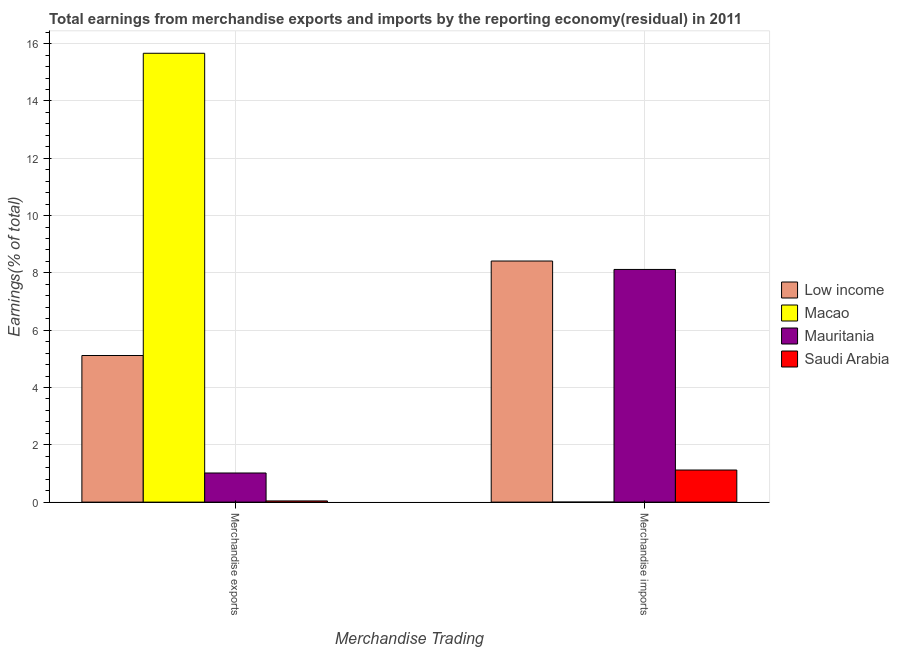Are the number of bars on each tick of the X-axis equal?
Your answer should be compact. No. How many bars are there on the 1st tick from the left?
Your answer should be very brief. 4. How many bars are there on the 1st tick from the right?
Your answer should be compact. 3. What is the earnings from merchandise exports in Macao?
Provide a succinct answer. 15.67. Across all countries, what is the maximum earnings from merchandise exports?
Your answer should be compact. 15.67. Across all countries, what is the minimum earnings from merchandise exports?
Give a very brief answer. 0.04. In which country was the earnings from merchandise exports maximum?
Your answer should be compact. Macao. What is the total earnings from merchandise imports in the graph?
Make the answer very short. 17.66. What is the difference between the earnings from merchandise exports in Low income and that in Macao?
Your response must be concise. -10.55. What is the difference between the earnings from merchandise exports in Mauritania and the earnings from merchandise imports in Low income?
Provide a succinct answer. -7.4. What is the average earnings from merchandise imports per country?
Provide a succinct answer. 4.41. What is the difference between the earnings from merchandise exports and earnings from merchandise imports in Mauritania?
Offer a terse response. -7.1. What is the ratio of the earnings from merchandise imports in Mauritania to that in Saudi Arabia?
Provide a succinct answer. 7.25. How many bars are there?
Offer a very short reply. 7. What is the difference between two consecutive major ticks on the Y-axis?
Give a very brief answer. 2. Does the graph contain any zero values?
Make the answer very short. Yes. Where does the legend appear in the graph?
Your answer should be compact. Center right. How are the legend labels stacked?
Your answer should be compact. Vertical. What is the title of the graph?
Provide a succinct answer. Total earnings from merchandise exports and imports by the reporting economy(residual) in 2011. What is the label or title of the X-axis?
Ensure brevity in your answer.  Merchandise Trading. What is the label or title of the Y-axis?
Keep it short and to the point. Earnings(% of total). What is the Earnings(% of total) in Low income in Merchandise exports?
Offer a very short reply. 5.12. What is the Earnings(% of total) of Macao in Merchandise exports?
Offer a terse response. 15.67. What is the Earnings(% of total) of Mauritania in Merchandise exports?
Keep it short and to the point. 1.02. What is the Earnings(% of total) in Saudi Arabia in Merchandise exports?
Your answer should be very brief. 0.04. What is the Earnings(% of total) of Low income in Merchandise imports?
Keep it short and to the point. 8.42. What is the Earnings(% of total) of Mauritania in Merchandise imports?
Make the answer very short. 8.12. What is the Earnings(% of total) of Saudi Arabia in Merchandise imports?
Offer a very short reply. 1.12. Across all Merchandise Trading, what is the maximum Earnings(% of total) of Low income?
Your answer should be compact. 8.42. Across all Merchandise Trading, what is the maximum Earnings(% of total) of Macao?
Make the answer very short. 15.67. Across all Merchandise Trading, what is the maximum Earnings(% of total) in Mauritania?
Your answer should be very brief. 8.12. Across all Merchandise Trading, what is the maximum Earnings(% of total) in Saudi Arabia?
Your response must be concise. 1.12. Across all Merchandise Trading, what is the minimum Earnings(% of total) of Low income?
Your answer should be very brief. 5.12. Across all Merchandise Trading, what is the minimum Earnings(% of total) in Mauritania?
Make the answer very short. 1.02. Across all Merchandise Trading, what is the minimum Earnings(% of total) in Saudi Arabia?
Offer a terse response. 0.04. What is the total Earnings(% of total) of Low income in the graph?
Your answer should be very brief. 13.53. What is the total Earnings(% of total) of Macao in the graph?
Your answer should be very brief. 15.67. What is the total Earnings(% of total) of Mauritania in the graph?
Give a very brief answer. 9.14. What is the total Earnings(% of total) in Saudi Arabia in the graph?
Your answer should be compact. 1.16. What is the difference between the Earnings(% of total) in Low income in Merchandise exports and that in Merchandise imports?
Give a very brief answer. -3.3. What is the difference between the Earnings(% of total) of Mauritania in Merchandise exports and that in Merchandise imports?
Make the answer very short. -7.1. What is the difference between the Earnings(% of total) of Saudi Arabia in Merchandise exports and that in Merchandise imports?
Your response must be concise. -1.08. What is the difference between the Earnings(% of total) of Low income in Merchandise exports and the Earnings(% of total) of Mauritania in Merchandise imports?
Offer a terse response. -3. What is the difference between the Earnings(% of total) of Low income in Merchandise exports and the Earnings(% of total) of Saudi Arabia in Merchandise imports?
Your response must be concise. 4. What is the difference between the Earnings(% of total) in Macao in Merchandise exports and the Earnings(% of total) in Mauritania in Merchandise imports?
Offer a terse response. 7.55. What is the difference between the Earnings(% of total) in Macao in Merchandise exports and the Earnings(% of total) in Saudi Arabia in Merchandise imports?
Keep it short and to the point. 14.55. What is the difference between the Earnings(% of total) of Mauritania in Merchandise exports and the Earnings(% of total) of Saudi Arabia in Merchandise imports?
Your response must be concise. -0.1. What is the average Earnings(% of total) of Low income per Merchandise Trading?
Ensure brevity in your answer.  6.77. What is the average Earnings(% of total) in Macao per Merchandise Trading?
Offer a terse response. 7.83. What is the average Earnings(% of total) of Mauritania per Merchandise Trading?
Ensure brevity in your answer.  4.57. What is the average Earnings(% of total) of Saudi Arabia per Merchandise Trading?
Your response must be concise. 0.58. What is the difference between the Earnings(% of total) of Low income and Earnings(% of total) of Macao in Merchandise exports?
Your answer should be very brief. -10.55. What is the difference between the Earnings(% of total) in Low income and Earnings(% of total) in Saudi Arabia in Merchandise exports?
Ensure brevity in your answer.  5.08. What is the difference between the Earnings(% of total) in Macao and Earnings(% of total) in Mauritania in Merchandise exports?
Keep it short and to the point. 14.65. What is the difference between the Earnings(% of total) in Macao and Earnings(% of total) in Saudi Arabia in Merchandise exports?
Make the answer very short. 15.62. What is the difference between the Earnings(% of total) of Mauritania and Earnings(% of total) of Saudi Arabia in Merchandise exports?
Keep it short and to the point. 0.98. What is the difference between the Earnings(% of total) in Low income and Earnings(% of total) in Mauritania in Merchandise imports?
Make the answer very short. 0.29. What is the difference between the Earnings(% of total) of Low income and Earnings(% of total) of Saudi Arabia in Merchandise imports?
Offer a terse response. 7.29. What is the difference between the Earnings(% of total) in Mauritania and Earnings(% of total) in Saudi Arabia in Merchandise imports?
Offer a terse response. 7. What is the ratio of the Earnings(% of total) of Low income in Merchandise exports to that in Merchandise imports?
Your response must be concise. 0.61. What is the ratio of the Earnings(% of total) in Mauritania in Merchandise exports to that in Merchandise imports?
Offer a very short reply. 0.13. What is the ratio of the Earnings(% of total) in Saudi Arabia in Merchandise exports to that in Merchandise imports?
Give a very brief answer. 0.04. What is the difference between the highest and the second highest Earnings(% of total) of Low income?
Provide a succinct answer. 3.3. What is the difference between the highest and the second highest Earnings(% of total) of Mauritania?
Provide a succinct answer. 7.1. What is the difference between the highest and the second highest Earnings(% of total) in Saudi Arabia?
Ensure brevity in your answer.  1.08. What is the difference between the highest and the lowest Earnings(% of total) of Low income?
Keep it short and to the point. 3.3. What is the difference between the highest and the lowest Earnings(% of total) in Macao?
Your answer should be compact. 15.67. What is the difference between the highest and the lowest Earnings(% of total) in Mauritania?
Ensure brevity in your answer.  7.1. What is the difference between the highest and the lowest Earnings(% of total) in Saudi Arabia?
Give a very brief answer. 1.08. 